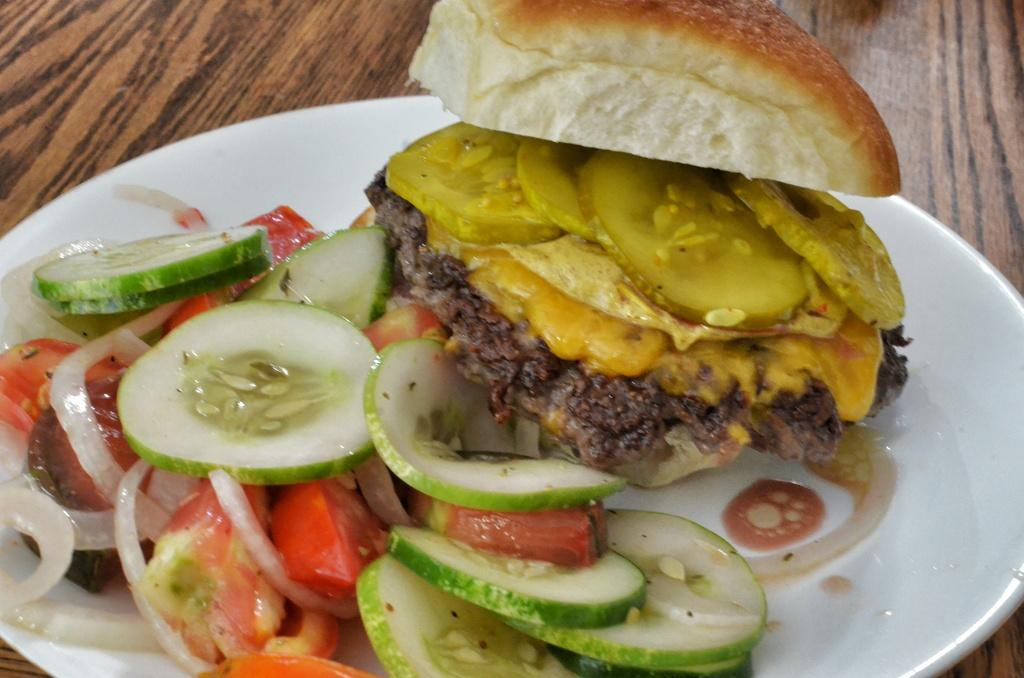What is the main food item visible in the image? There is a food item served in a plate in the image. Where is the plate with the food item located? The plate is placed on a table. What type of mark can be seen on the cloth in the image? There is no cloth present in the image, and therefore no mark can be seen on it. 